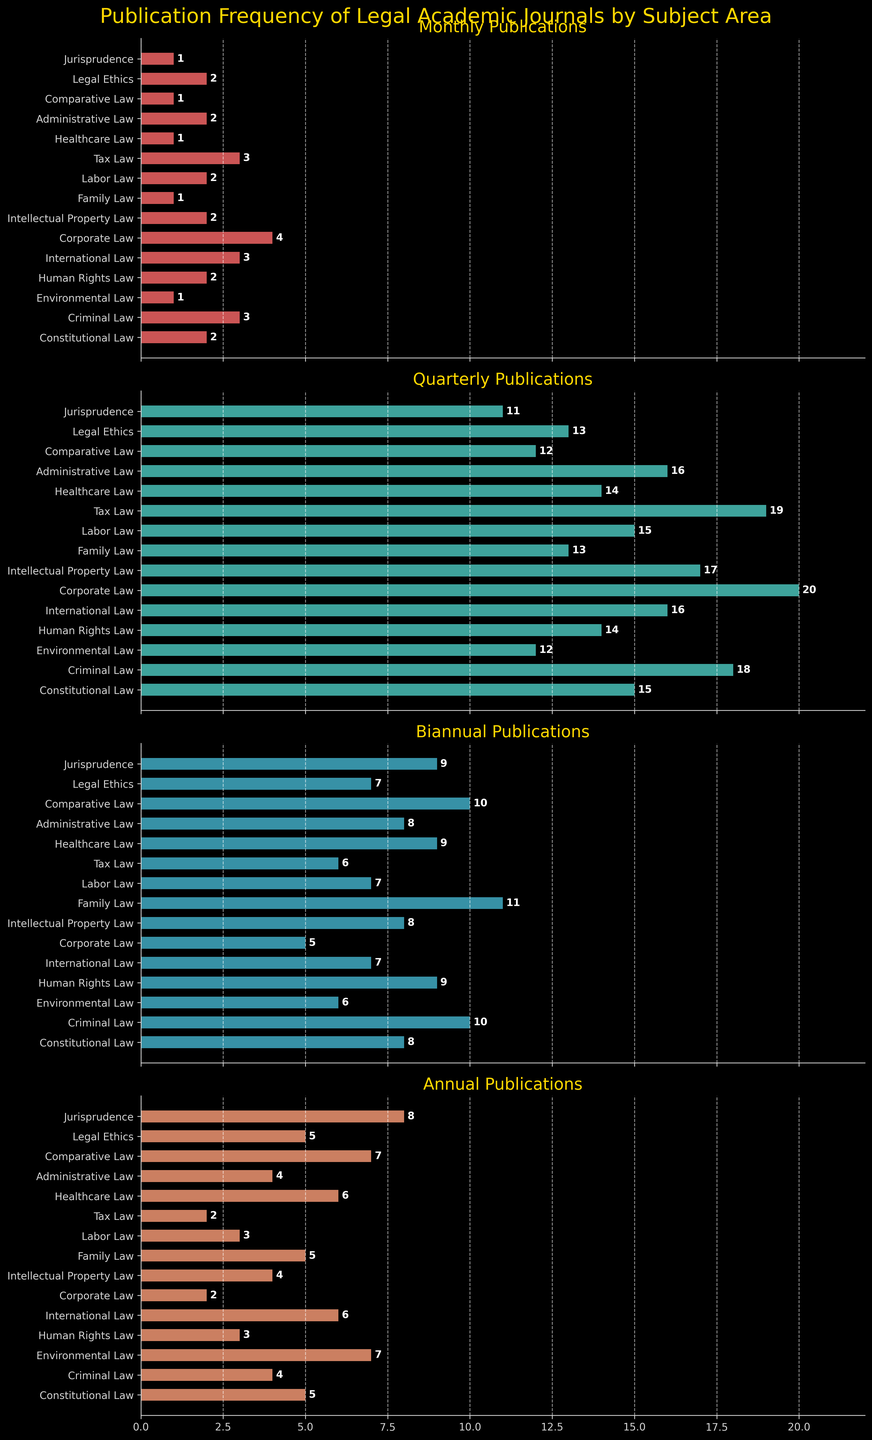Which subject has the highest number of quarterly publications? Look at the bar heights in the 'Quarterly Publications' subplot. Corporate Law has the highest bar, indicating it has the highest number of quarterly publications.
Answer: Corporate Law How many total annual publications are there for Constitutional Law and Environmental Law combined? Check the 'Annual Publications' subplot. Constitutional Law has 5 and Environmental Law has 7. So, 5 + 7 = 12.
Answer: 12 Which subject area has more monthly publications: Intellectual Property Law or Labor Law? Refer to the 'Monthly Publications' subplot. Both Intellectual Property Law and Labor Law have 2 monthly publications each.
Answer: Both have equal What's the total number of biannual publications for Tax Law and Jurisprudence? In the 'Biannual Publications' subplot, Tax Law has 6 and Jurisprudence has 9. Adding them gives 6 + 9 = 15.
Answer: 15 Which subject has the least annual publications, and how many does it have? In the 'Annual Publications' subplot, Corporate Law and Tax Law both have the shortest bars, indicating they have the least annual publications, which is 2.
Answer: Corporate Law and Tax Law, 2 Among the subjects with at least 10 biannual publications, which has the highest number of quarterly publications? In the 'Biannual Publications' subplot, Family Law and Comparative Law have at least 10 biannual publications. Of these, Family Law has 13 quarterly publications (Comparative Law has 12).
Answer: Family Law Compare the number of monthly and biannual publications for Human Rights Law. Which is greater and by how much? In the 'Monthly Publications' subplot, Human Rights Law has 2 publications. In the 'Biannual Publications’ subplot, it has 9 publications. So, 9 - 2 = 7 more biannual publications.
Answer: Biannual, 7 What is the difference in the number of quarterly publications between Corporate Law and Constitutional Law? Check the 'Quarterly Publications' subplot. Corporate Law has 20 publications, and Constitutional Law has 15. The difference is 20 - 15 = 5.
Answer: 5 How does the number of biannual publications in Family Law compare to that in Legal Ethics? In the ‘Biannual Publications’ subplot, Family Law has 11 publications whereas Legal Ethics has 7. So, Family Law has 4 more biannual publications than Legal Ethics.
Answer: Family Law has 4 more Which subject has a higher overall publication count for all categories: Criminal Law or Healthcare Law? Add the publication counts for all categories in Criminal Law (3+18+10+4=35) and Healthcare Law (1+14+9+6=30). Criminal Law has more overall publications.
Answer: Criminal Law 